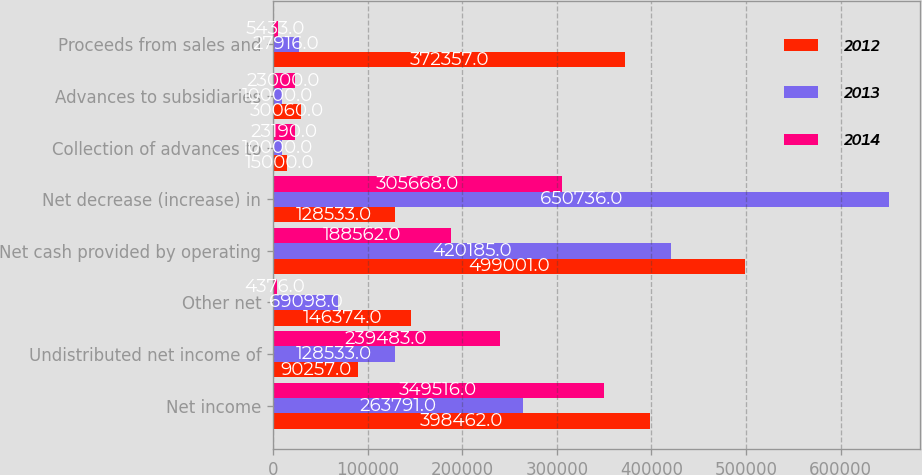Convert chart to OTSL. <chart><loc_0><loc_0><loc_500><loc_500><stacked_bar_chart><ecel><fcel>Net income<fcel>Undistributed net income of<fcel>Other net<fcel>Net cash provided by operating<fcel>Net decrease (increase) in<fcel>Collection of advances to<fcel>Advances to subsidiaries<fcel>Proceeds from sales and<nl><fcel>2012<fcel>398462<fcel>90257<fcel>146374<fcel>499001<fcel>128533<fcel>15000<fcel>30060<fcel>372357<nl><fcel>2013<fcel>263791<fcel>128533<fcel>69098<fcel>420185<fcel>650736<fcel>10000<fcel>10000<fcel>27916<nl><fcel>2014<fcel>349516<fcel>239483<fcel>4376<fcel>188562<fcel>305668<fcel>23190<fcel>23000<fcel>5433<nl></chart> 